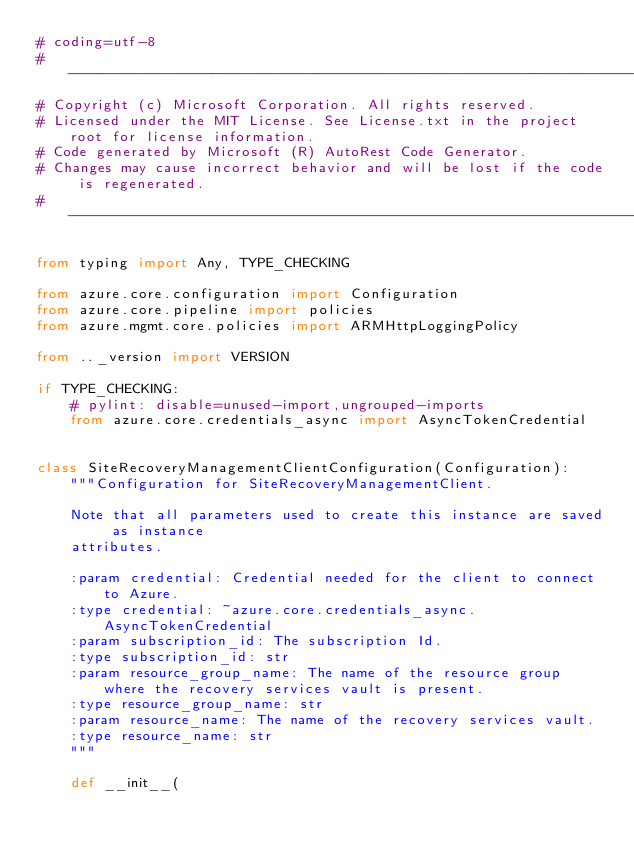<code> <loc_0><loc_0><loc_500><loc_500><_Python_># coding=utf-8
# --------------------------------------------------------------------------
# Copyright (c) Microsoft Corporation. All rights reserved.
# Licensed under the MIT License. See License.txt in the project root for license information.
# Code generated by Microsoft (R) AutoRest Code Generator.
# Changes may cause incorrect behavior and will be lost if the code is regenerated.
# --------------------------------------------------------------------------

from typing import Any, TYPE_CHECKING

from azure.core.configuration import Configuration
from azure.core.pipeline import policies
from azure.mgmt.core.policies import ARMHttpLoggingPolicy

from .._version import VERSION

if TYPE_CHECKING:
    # pylint: disable=unused-import,ungrouped-imports
    from azure.core.credentials_async import AsyncTokenCredential


class SiteRecoveryManagementClientConfiguration(Configuration):
    """Configuration for SiteRecoveryManagementClient.

    Note that all parameters used to create this instance are saved as instance
    attributes.

    :param credential: Credential needed for the client to connect to Azure.
    :type credential: ~azure.core.credentials_async.AsyncTokenCredential
    :param subscription_id: The subscription Id.
    :type subscription_id: str
    :param resource_group_name: The name of the resource group where the recovery services vault is present.
    :type resource_group_name: str
    :param resource_name: The name of the recovery services vault.
    :type resource_name: str
    """

    def __init__(</code> 